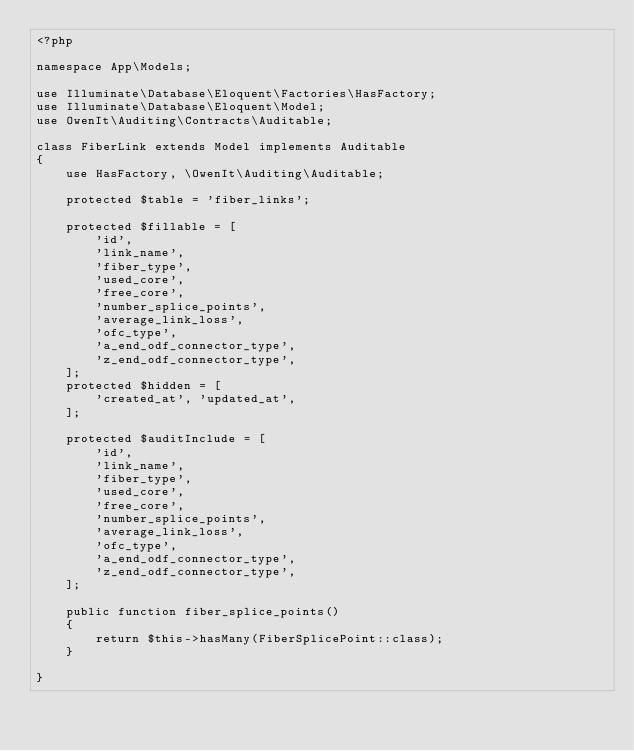Convert code to text. <code><loc_0><loc_0><loc_500><loc_500><_PHP_><?php

namespace App\Models;

use Illuminate\Database\Eloquent\Factories\HasFactory;
use Illuminate\Database\Eloquent\Model;
use OwenIt\Auditing\Contracts\Auditable;

class FiberLink extends Model implements Auditable
{
    use HasFactory, \OwenIt\Auditing\Auditable;

    protected $table = 'fiber_links';

    protected $fillable = [
        'id',
        'link_name',
        'fiber_type',
        'used_core',
        'free_core',
        'number_splice_points',
        'average_link_loss',
        'ofc_type',
        'a_end_odf_connector_type',
        'z_end_odf_connector_type',
    ];
    protected $hidden = [
        'created_at', 'updated_at',
    ];

    protected $auditInclude = [
        'id',
        'link_name',
        'fiber_type',
        'used_core',
        'free_core',
        'number_splice_points',
        'average_link_loss',
        'ofc_type',
        'a_end_odf_connector_type',
        'z_end_odf_connector_type',
    ];

    public function fiber_splice_points()
    {
        return $this->hasMany(FiberSplicePoint::class);
    }

}
</code> 